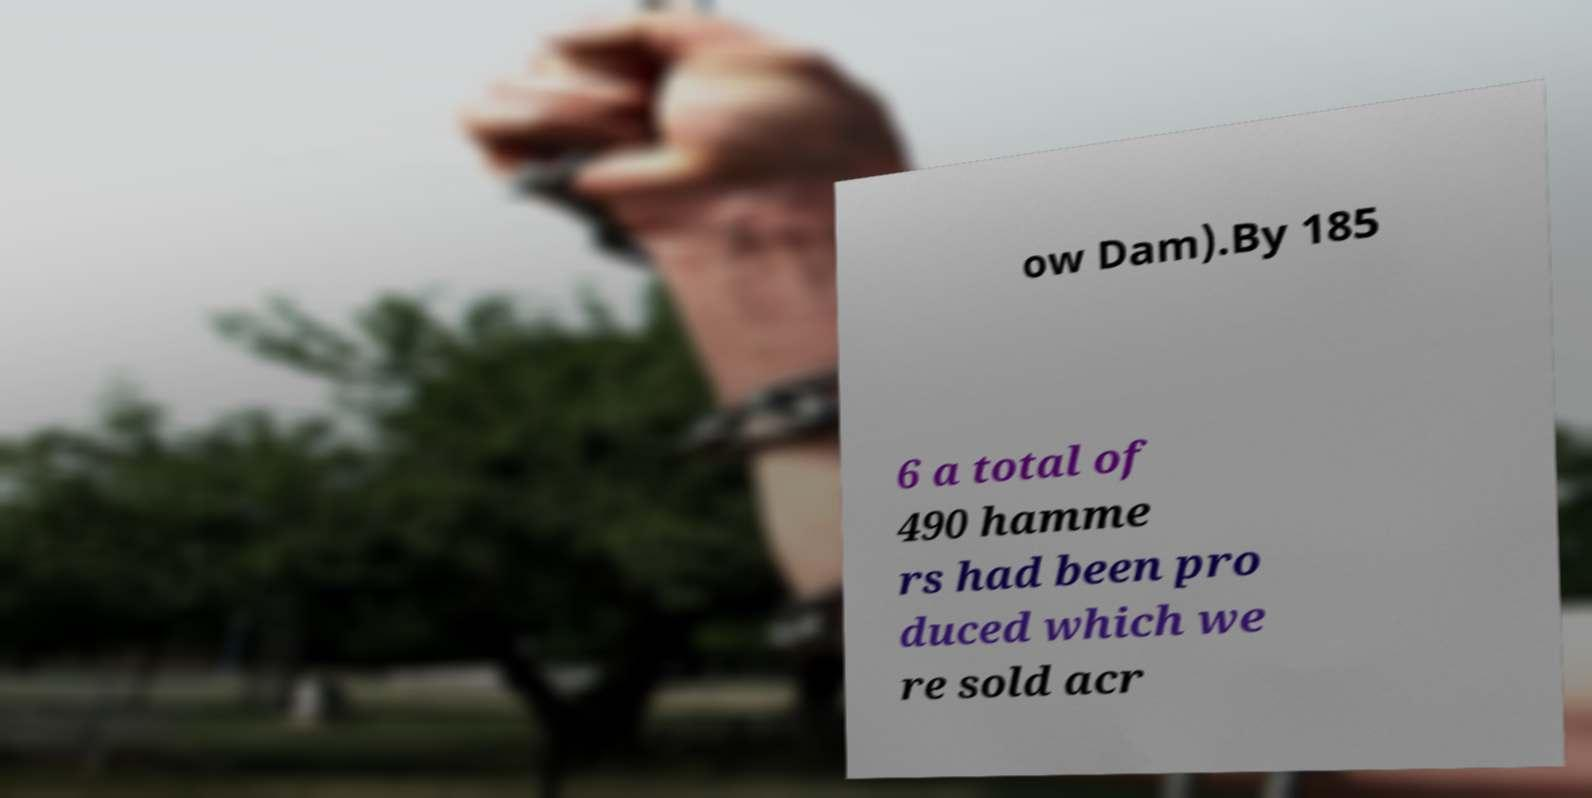Can you accurately transcribe the text from the provided image for me? ow Dam).By 185 6 a total of 490 hamme rs had been pro duced which we re sold acr 